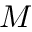<formula> <loc_0><loc_0><loc_500><loc_500>M</formula> 